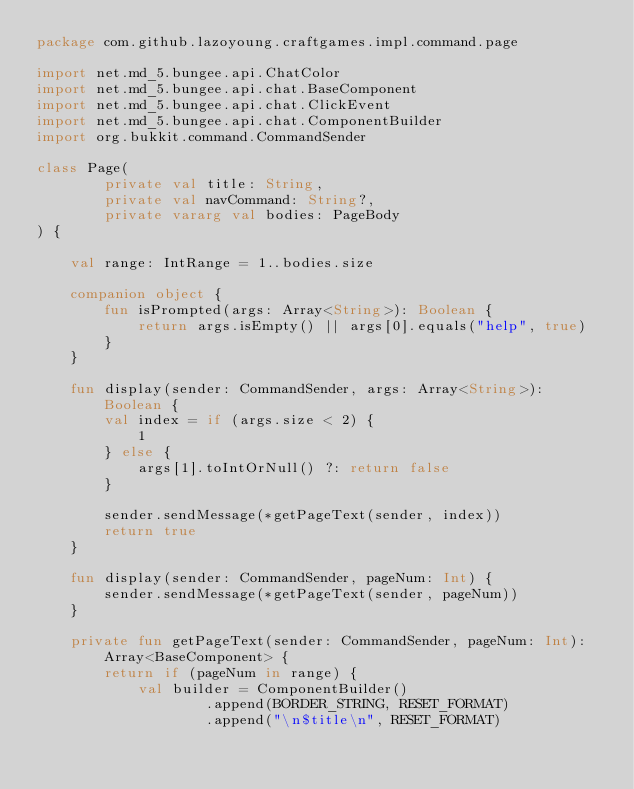Convert code to text. <code><loc_0><loc_0><loc_500><loc_500><_Kotlin_>package com.github.lazoyoung.craftgames.impl.command.page

import net.md_5.bungee.api.ChatColor
import net.md_5.bungee.api.chat.BaseComponent
import net.md_5.bungee.api.chat.ClickEvent
import net.md_5.bungee.api.chat.ComponentBuilder
import org.bukkit.command.CommandSender

class Page(
        private val title: String,
        private val navCommand: String?,
        private vararg val bodies: PageBody
) {

    val range: IntRange = 1..bodies.size

    companion object {
        fun isPrompted(args: Array<String>): Boolean {
            return args.isEmpty() || args[0].equals("help", true)
        }
    }

    fun display(sender: CommandSender, args: Array<String>): Boolean {
        val index = if (args.size < 2) {
            1
        } else {
            args[1].toIntOrNull() ?: return false
        }

        sender.sendMessage(*getPageText(sender, index))
        return true
    }

    fun display(sender: CommandSender, pageNum: Int) {
        sender.sendMessage(*getPageText(sender, pageNum))
    }

    private fun getPageText(sender: CommandSender, pageNum: Int): Array<BaseComponent> {
        return if (pageNum in range) {
            val builder = ComponentBuilder()
                    .append(BORDER_STRING, RESET_FORMAT)
                    .append("\n$title\n", RESET_FORMAT)</code> 